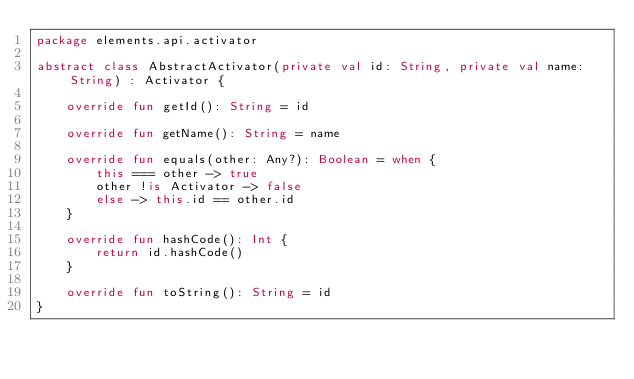<code> <loc_0><loc_0><loc_500><loc_500><_Kotlin_>package elements.api.activator

abstract class AbstractActivator(private val id: String, private val name: String) : Activator {

    override fun getId(): String = id

    override fun getName(): String = name

    override fun equals(other: Any?): Boolean = when {
        this === other -> true
        other !is Activator -> false
        else -> this.id == other.id
    }

    override fun hashCode(): Int {
        return id.hashCode()
    }

    override fun toString(): String = id
}</code> 